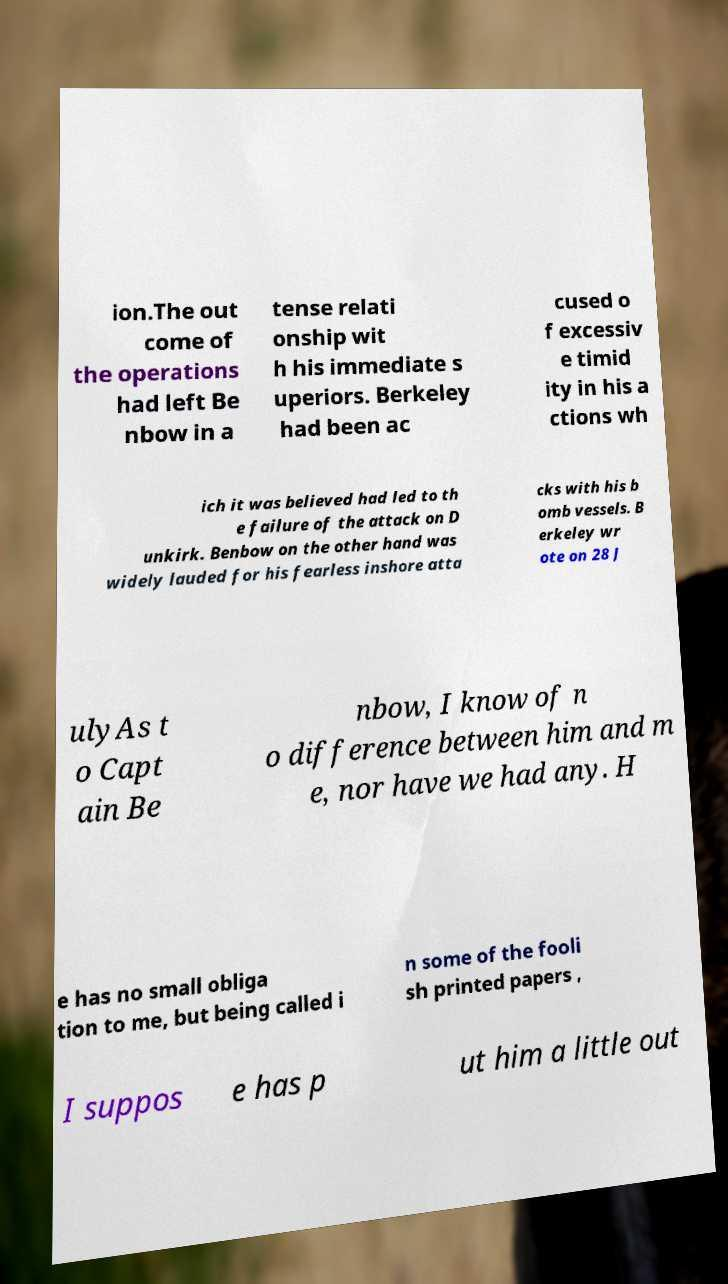There's text embedded in this image that I need extracted. Can you transcribe it verbatim? ion.The out come of the operations had left Be nbow in a tense relati onship wit h his immediate s uperiors. Berkeley had been ac cused o f excessiv e timid ity in his a ctions wh ich it was believed had led to th e failure of the attack on D unkirk. Benbow on the other hand was widely lauded for his fearless inshore atta cks with his b omb vessels. B erkeley wr ote on 28 J ulyAs t o Capt ain Be nbow, I know of n o difference between him and m e, nor have we had any. H e has no small obliga tion to me, but being called i n some of the fooli sh printed papers , I suppos e has p ut him a little out 